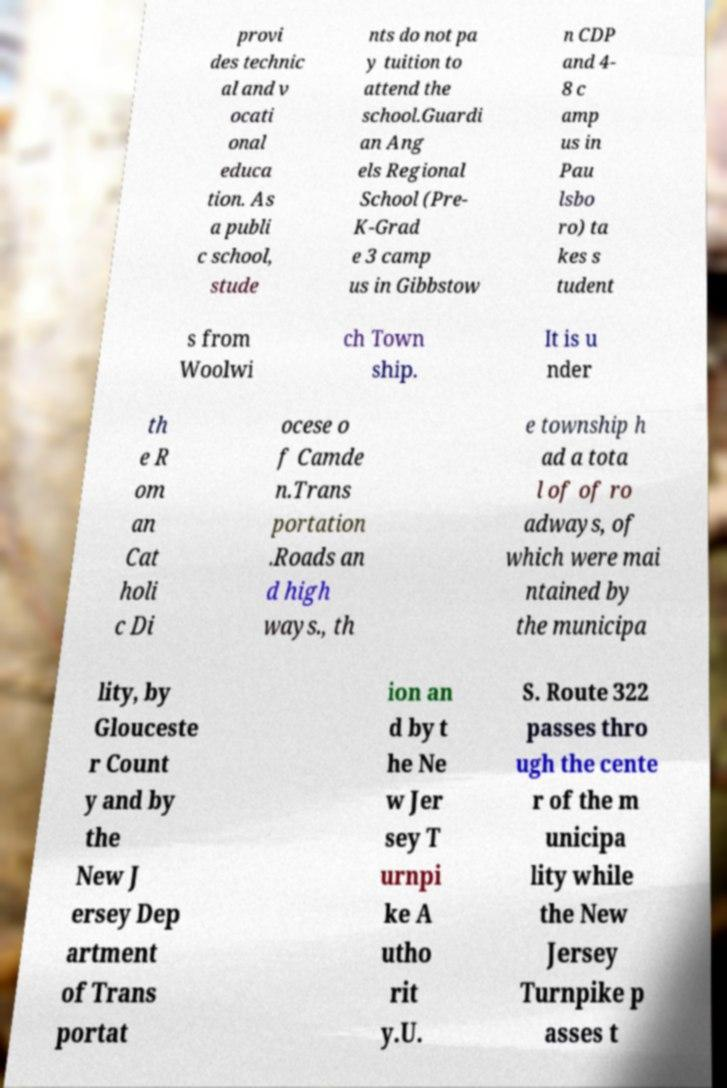Could you extract and type out the text from this image? provi des technic al and v ocati onal educa tion. As a publi c school, stude nts do not pa y tuition to attend the school.Guardi an Ang els Regional School (Pre- K-Grad e 3 camp us in Gibbstow n CDP and 4- 8 c amp us in Pau lsbo ro) ta kes s tudent s from Woolwi ch Town ship. It is u nder th e R om an Cat holi c Di ocese o f Camde n.Trans portation .Roads an d high ways., th e township h ad a tota l of of ro adways, of which were mai ntained by the municipa lity, by Glouceste r Count y and by the New J ersey Dep artment of Trans portat ion an d by t he Ne w Jer sey T urnpi ke A utho rit y.U. S. Route 322 passes thro ugh the cente r of the m unicipa lity while the New Jersey Turnpike p asses t 